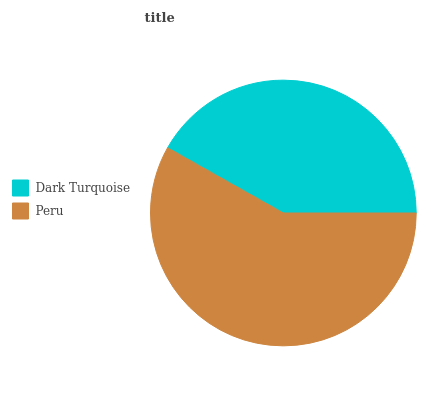Is Dark Turquoise the minimum?
Answer yes or no. Yes. Is Peru the maximum?
Answer yes or no. Yes. Is Peru the minimum?
Answer yes or no. No. Is Peru greater than Dark Turquoise?
Answer yes or no. Yes. Is Dark Turquoise less than Peru?
Answer yes or no. Yes. Is Dark Turquoise greater than Peru?
Answer yes or no. No. Is Peru less than Dark Turquoise?
Answer yes or no. No. Is Peru the high median?
Answer yes or no. Yes. Is Dark Turquoise the low median?
Answer yes or no. Yes. Is Dark Turquoise the high median?
Answer yes or no. No. Is Peru the low median?
Answer yes or no. No. 